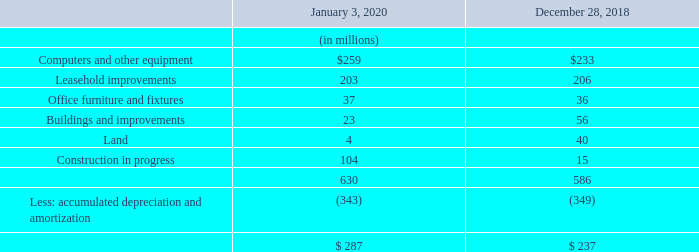Note 12—Property, Plant and Equipment
Property, plant and equipment, net consisted of the following:
Depreciation expense was $61 million, $56 million and $55 million for fiscal 2019, 2018 and 2017, respectively.
What was the depreciation expense in 2019, 2018 and 2017 respectively? $61 million, $56 million, $55 million. What was the Computers and other equipment in January 2020?
Answer scale should be: million. $259. What was the Leasehold improvements in 2018?
Answer scale should be: million. 206. In which period was Computers and other equipment less than 250 million? Locate and analyze computers and other equipment in row 3
answer: 2018. What was the change in the Leasehold improvements from 2018 to 2020?
Answer scale should be: million. 203 - 206
Answer: -3. What was the percentage change in the Office furniture and fixtures from 2018 to 2020?
Answer scale should be: percent. (37-36)/36
Answer: 2.78. 